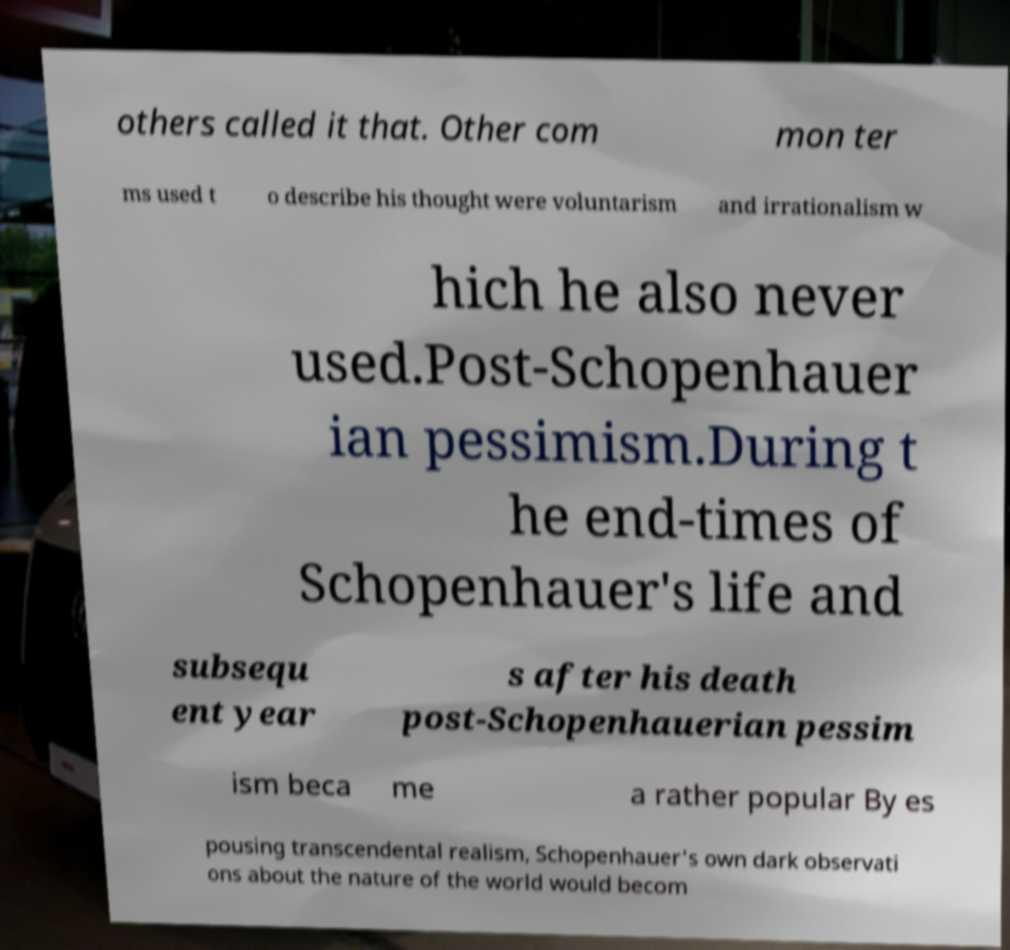What messages or text are displayed in this image? I need them in a readable, typed format. others called it that. Other com mon ter ms used t o describe his thought were voluntarism and irrationalism w hich he also never used.Post-Schopenhauer ian pessimism.During t he end-times of Schopenhauer's life and subsequ ent year s after his death post-Schopenhauerian pessim ism beca me a rather popular By es pousing transcendental realism, Schopenhauer's own dark observati ons about the nature of the world would becom 